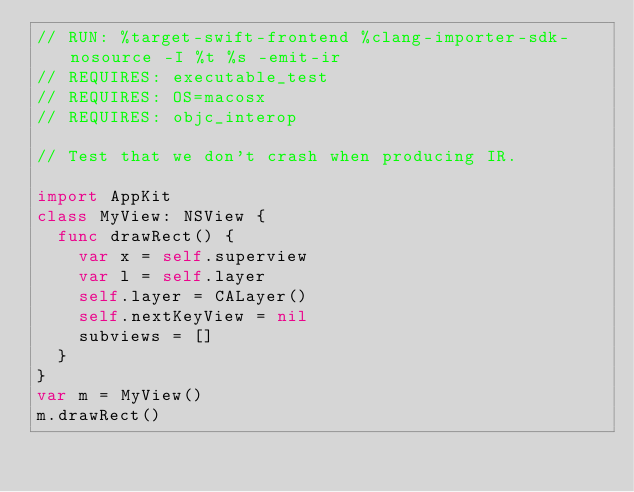Convert code to text. <code><loc_0><loc_0><loc_500><loc_500><_Swift_>// RUN: %target-swift-frontend %clang-importer-sdk-nosource -I %t %s -emit-ir
// REQUIRES: executable_test
// REQUIRES: OS=macosx
// REQUIRES: objc_interop

// Test that we don't crash when producing IR.

import AppKit
class MyView: NSView {
  func drawRect() {
    var x = self.superview
    var l = self.layer
    self.layer = CALayer()
    self.nextKeyView = nil
    subviews = []
  }    
}
var m = MyView()
m.drawRect()
</code> 